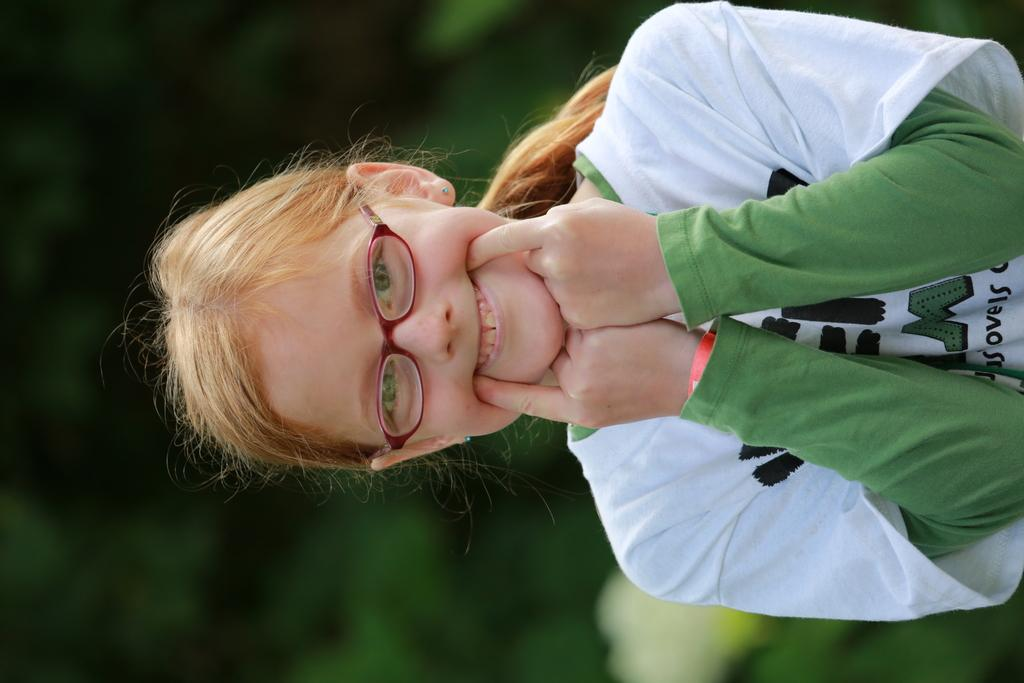Who is the main subject in the image? There is a girl in the image. What can be observed about the background in the image? The background of the image is blurred. What type of scale is the girl using to weigh the dolls in the image? There is no scale or dolls present in the image. What kind of structure can be seen in the background of the image? There is no structure visible in the background of the image; it is blurred. 